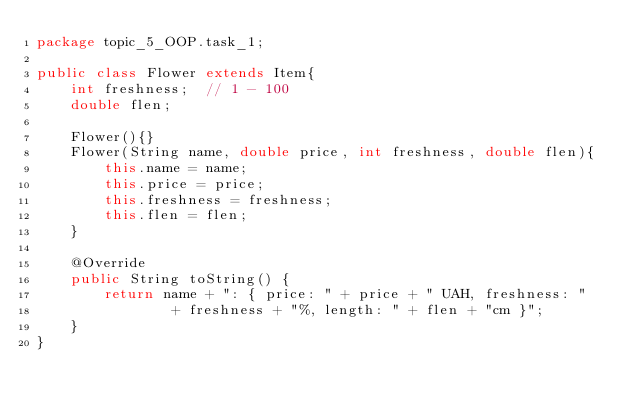<code> <loc_0><loc_0><loc_500><loc_500><_Java_>package topic_5_OOP.task_1;

public class Flower extends Item{
    int freshness;  // 1 - 100
    double flen;

    Flower(){}
    Flower(String name, double price, int freshness, double flen){
        this.name = name;
        this.price = price;
        this.freshness = freshness;
        this.flen = flen;
    }

    @Override
    public String toString() {
        return name + ": { price: " + price + " UAH, freshness: "
                + freshness + "%, length: " + flen + "cm }";
    }
}
</code> 